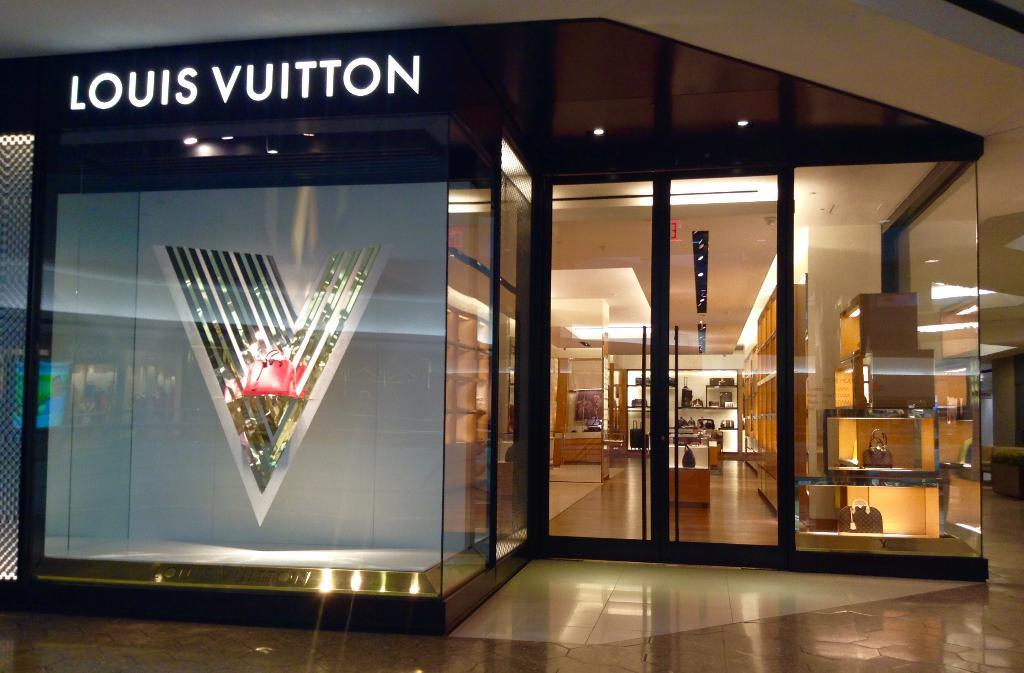<image>
Present a compact description of the photo's key features. An exterior of a Louis Vuitton store in a mall includes a huge letter V in the window. 